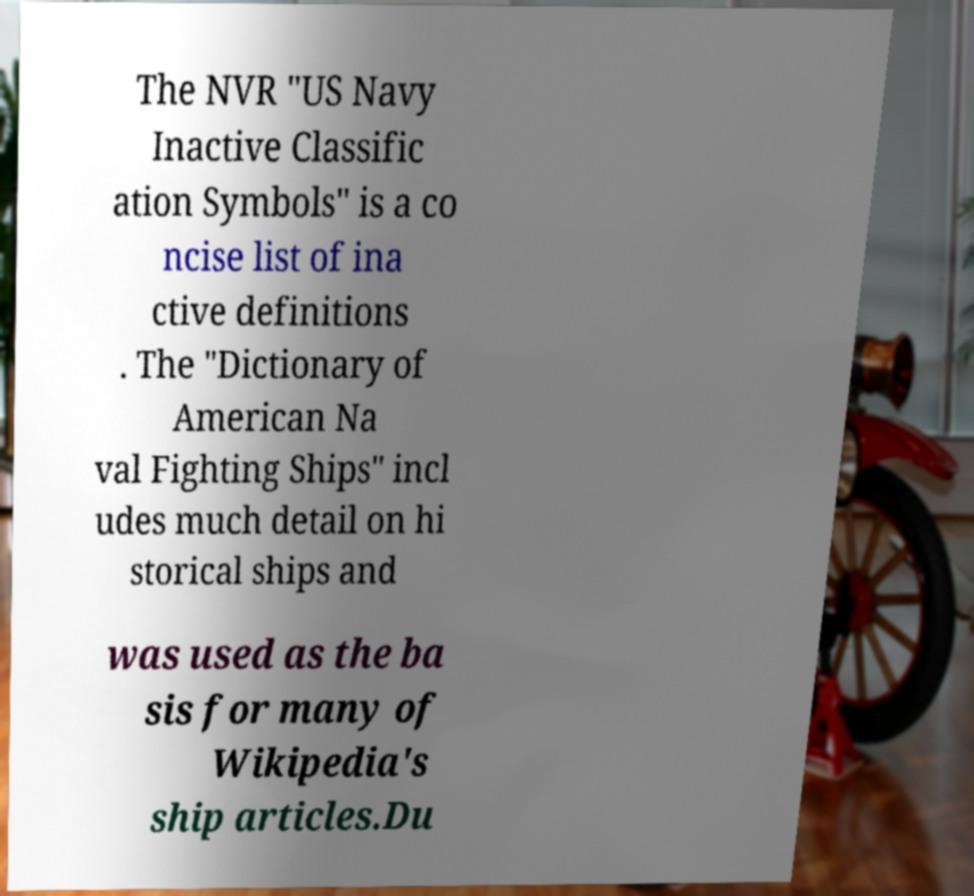What messages or text are displayed in this image? I need them in a readable, typed format. The NVR "US Navy Inactive Classific ation Symbols" is a co ncise list of ina ctive definitions . The "Dictionary of American Na val Fighting Ships" incl udes much detail on hi storical ships and was used as the ba sis for many of Wikipedia's ship articles.Du 